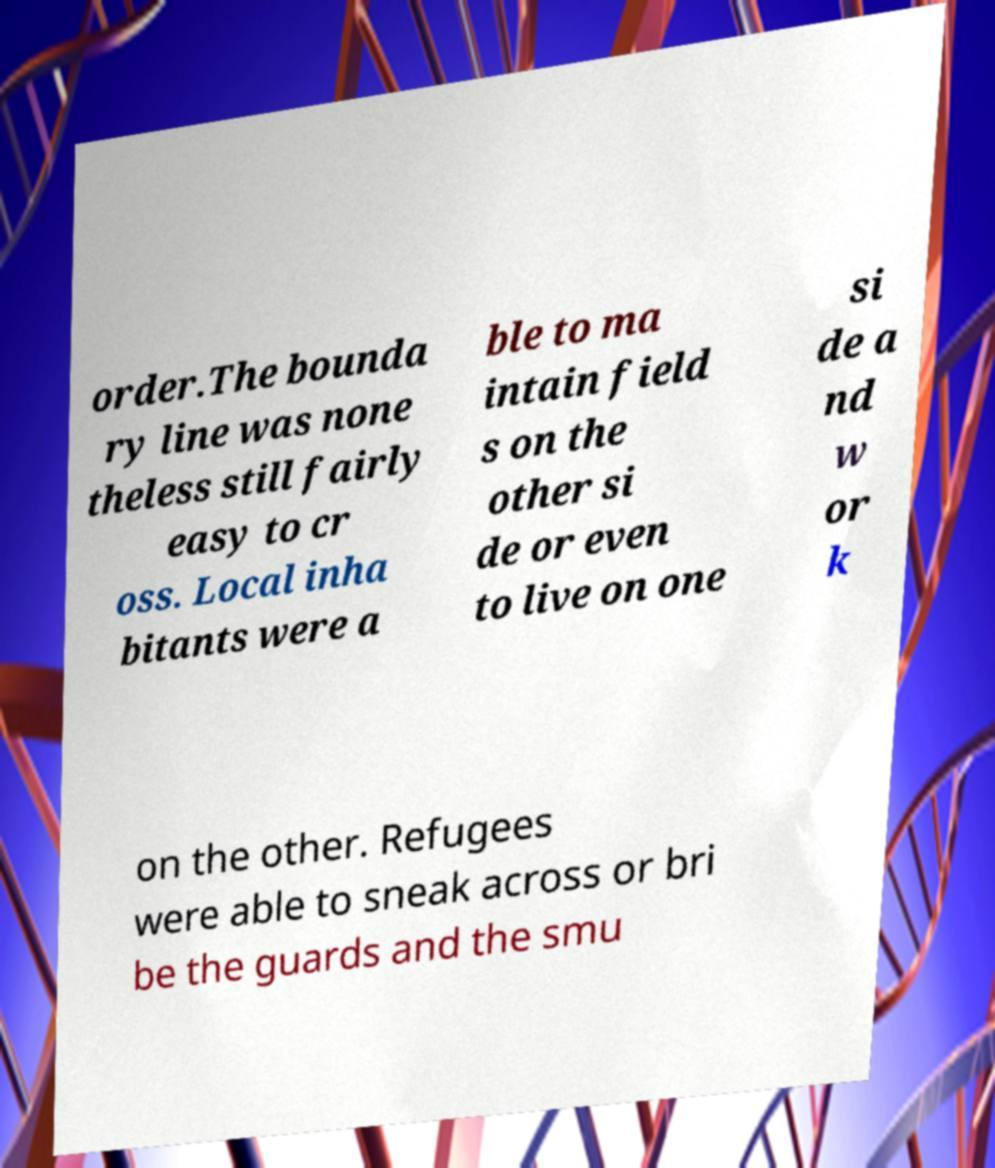Could you extract and type out the text from this image? order.The bounda ry line was none theless still fairly easy to cr oss. Local inha bitants were a ble to ma intain field s on the other si de or even to live on one si de a nd w or k on the other. Refugees were able to sneak across or bri be the guards and the smu 